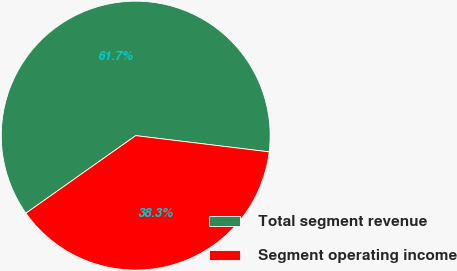<chart> <loc_0><loc_0><loc_500><loc_500><pie_chart><fcel>Total segment revenue<fcel>Segment operating income<nl><fcel>61.72%<fcel>38.28%<nl></chart> 